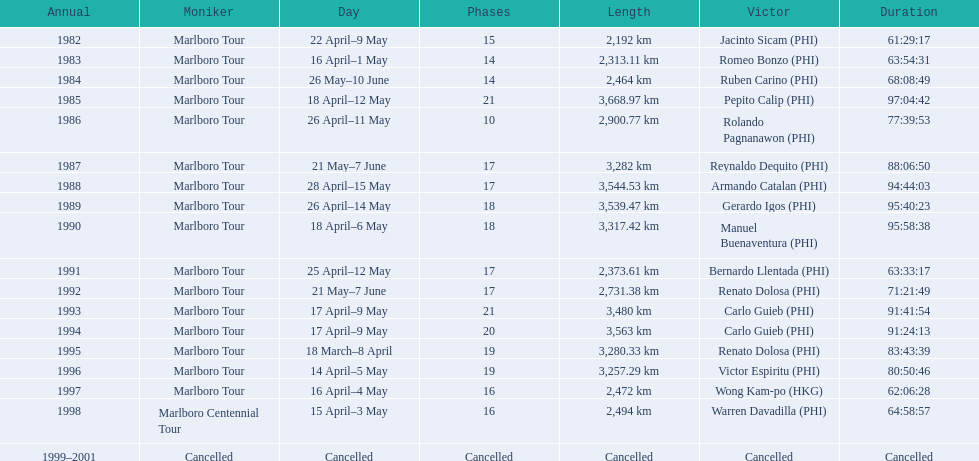What are the distances travelled on the tour? 2,192 km, 2,313.11 km, 2,464 km, 3,668.97 km, 2,900.77 km, 3,282 km, 3,544.53 km, 3,539.47 km, 3,317.42 km, 2,373.61 km, 2,731.38 km, 3,480 km, 3,563 km, 3,280.33 km, 3,257.29 km, 2,472 km, 2,494 km. Which of these are the largest? 3,668.97 km. 